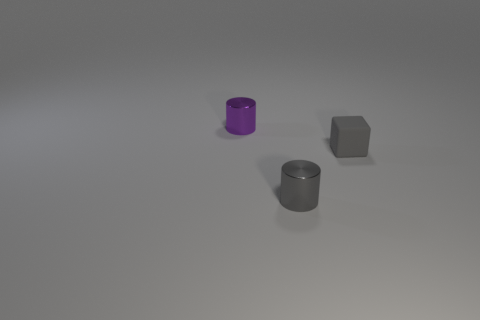Add 2 tiny purple metal cylinders. How many objects exist? 5 Subtract all cylinders. How many objects are left? 1 Subtract 0 brown cylinders. How many objects are left? 3 Subtract all matte things. Subtract all tiny purple shiny cylinders. How many objects are left? 1 Add 1 small objects. How many small objects are left? 4 Add 1 small purple metal cylinders. How many small purple metal cylinders exist? 2 